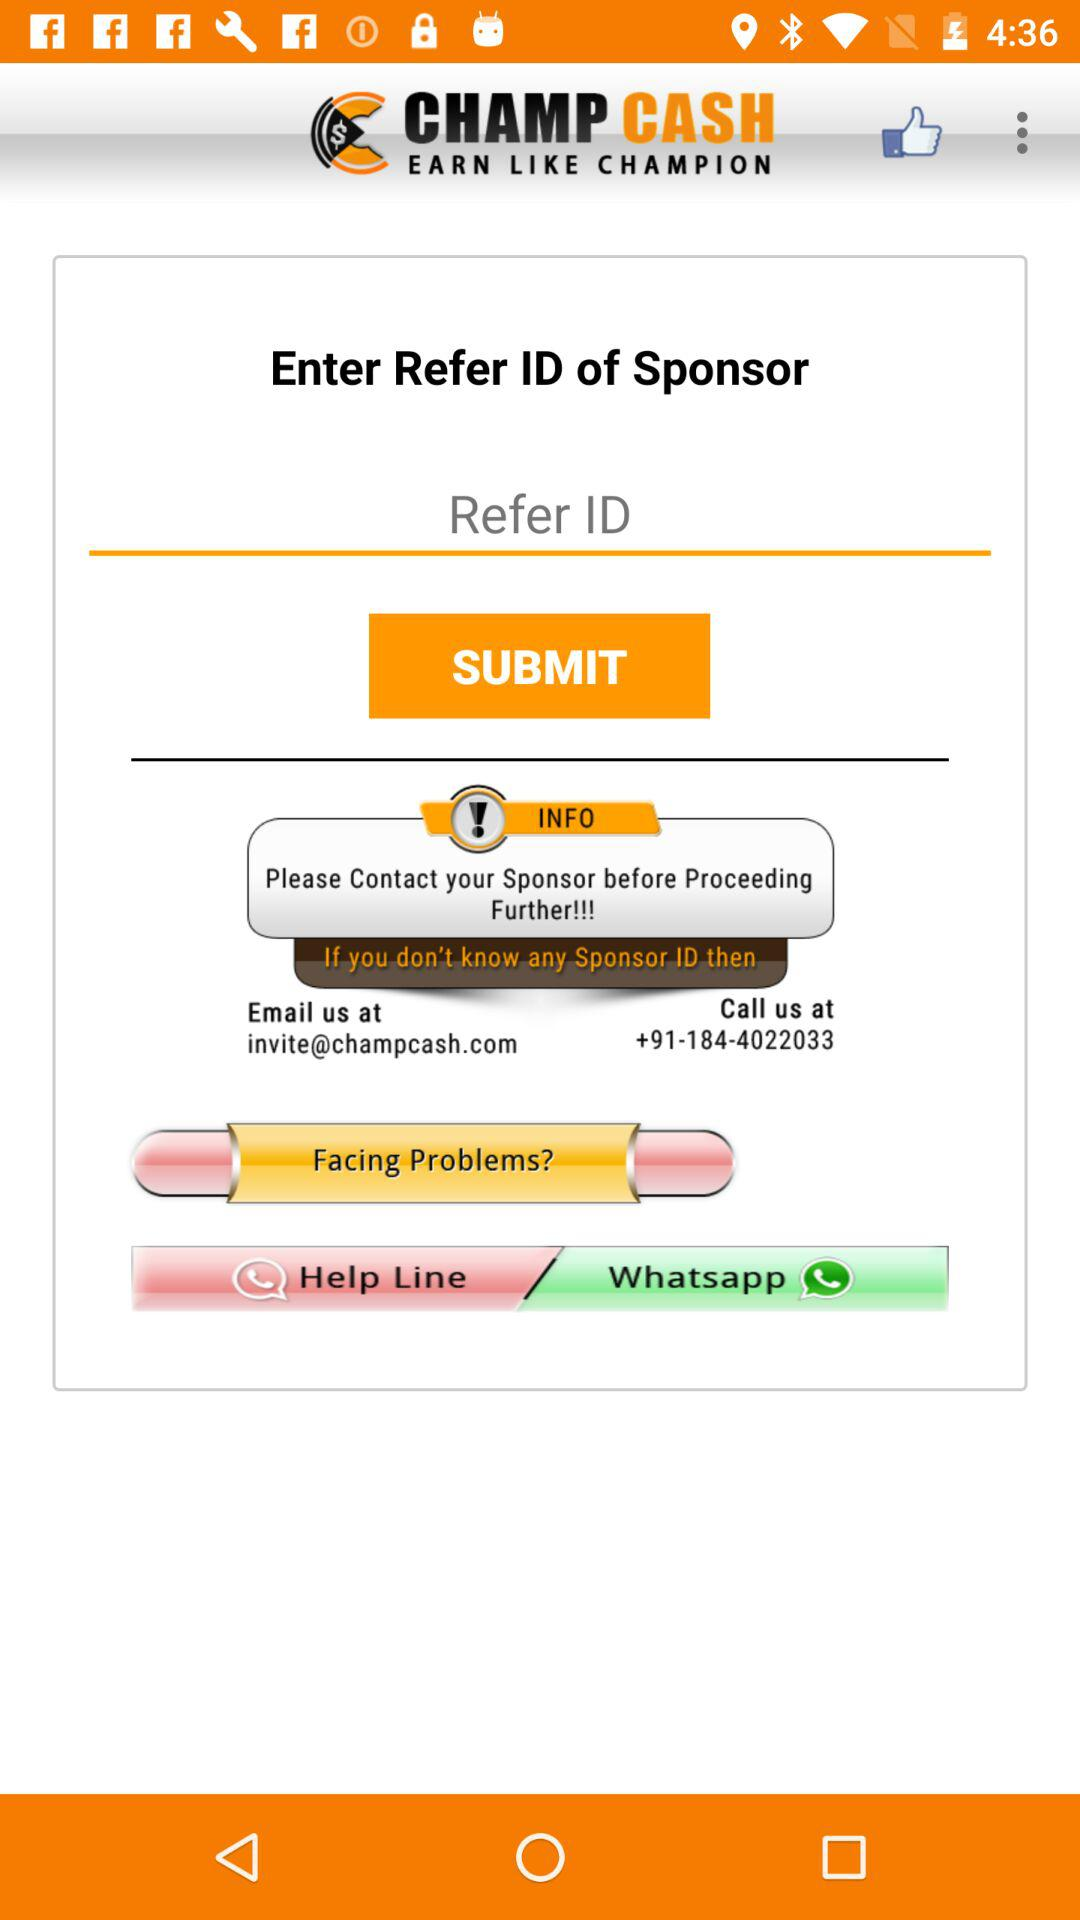What's the email address? The email address is invite@champcash.com. 